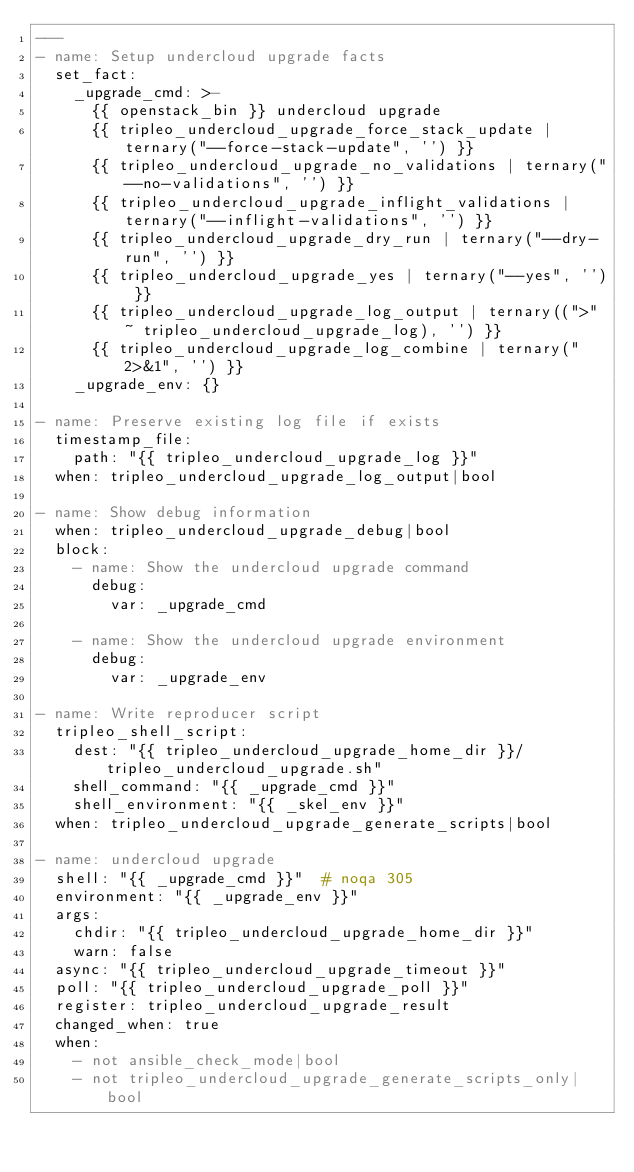<code> <loc_0><loc_0><loc_500><loc_500><_YAML_>---
- name: Setup undercloud upgrade facts
  set_fact:
    _upgrade_cmd: >-
      {{ openstack_bin }} undercloud upgrade
      {{ tripleo_undercloud_upgrade_force_stack_update | ternary("--force-stack-update", '') }}
      {{ tripleo_undercloud_upgrade_no_validations | ternary("--no-validations", '') }}
      {{ tripleo_undercloud_upgrade_inflight_validations | ternary("--inflight-validations", '') }}
      {{ tripleo_undercloud_upgrade_dry_run | ternary("--dry-run", '') }}
      {{ tripleo_undercloud_upgrade_yes | ternary("--yes", '') }}
      {{ tripleo_undercloud_upgrade_log_output | ternary((">" ~ tripleo_undercloud_upgrade_log), '') }}
      {{ tripleo_undercloud_upgrade_log_combine | ternary("2>&1", '') }}
    _upgrade_env: {}

- name: Preserve existing log file if exists
  timestamp_file:
    path: "{{ tripleo_undercloud_upgrade_log }}"
  when: tripleo_undercloud_upgrade_log_output|bool

- name: Show debug information
  when: tripleo_undercloud_upgrade_debug|bool
  block:
    - name: Show the undercloud upgrade command
      debug:
        var: _upgrade_cmd

    - name: Show the undercloud upgrade environment
      debug:
        var: _upgrade_env

- name: Write reproducer script
  tripleo_shell_script:
    dest: "{{ tripleo_undercloud_upgrade_home_dir }}/tripleo_undercloud_upgrade.sh"
    shell_command: "{{ _upgrade_cmd }}"
    shell_environment: "{{ _skel_env }}"
  when: tripleo_undercloud_upgrade_generate_scripts|bool

- name: undercloud upgrade
  shell: "{{ _upgrade_cmd }}"  # noqa 305
  environment: "{{ _upgrade_env }}"
  args:
    chdir: "{{ tripleo_undercloud_upgrade_home_dir }}"
    warn: false
  async: "{{ tripleo_undercloud_upgrade_timeout }}"
  poll: "{{ tripleo_undercloud_upgrade_poll }}"
  register: tripleo_undercloud_upgrade_result
  changed_when: true
  when:
    - not ansible_check_mode|bool
    - not tripleo_undercloud_upgrade_generate_scripts_only|bool
</code> 